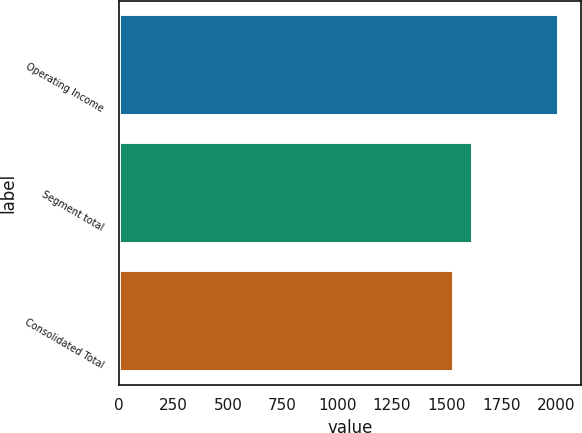Convert chart to OTSL. <chart><loc_0><loc_0><loc_500><loc_500><bar_chart><fcel>Operating Income<fcel>Segment total<fcel>Consolidated Total<nl><fcel>2016<fcel>1620.2<fcel>1535.1<nl></chart> 